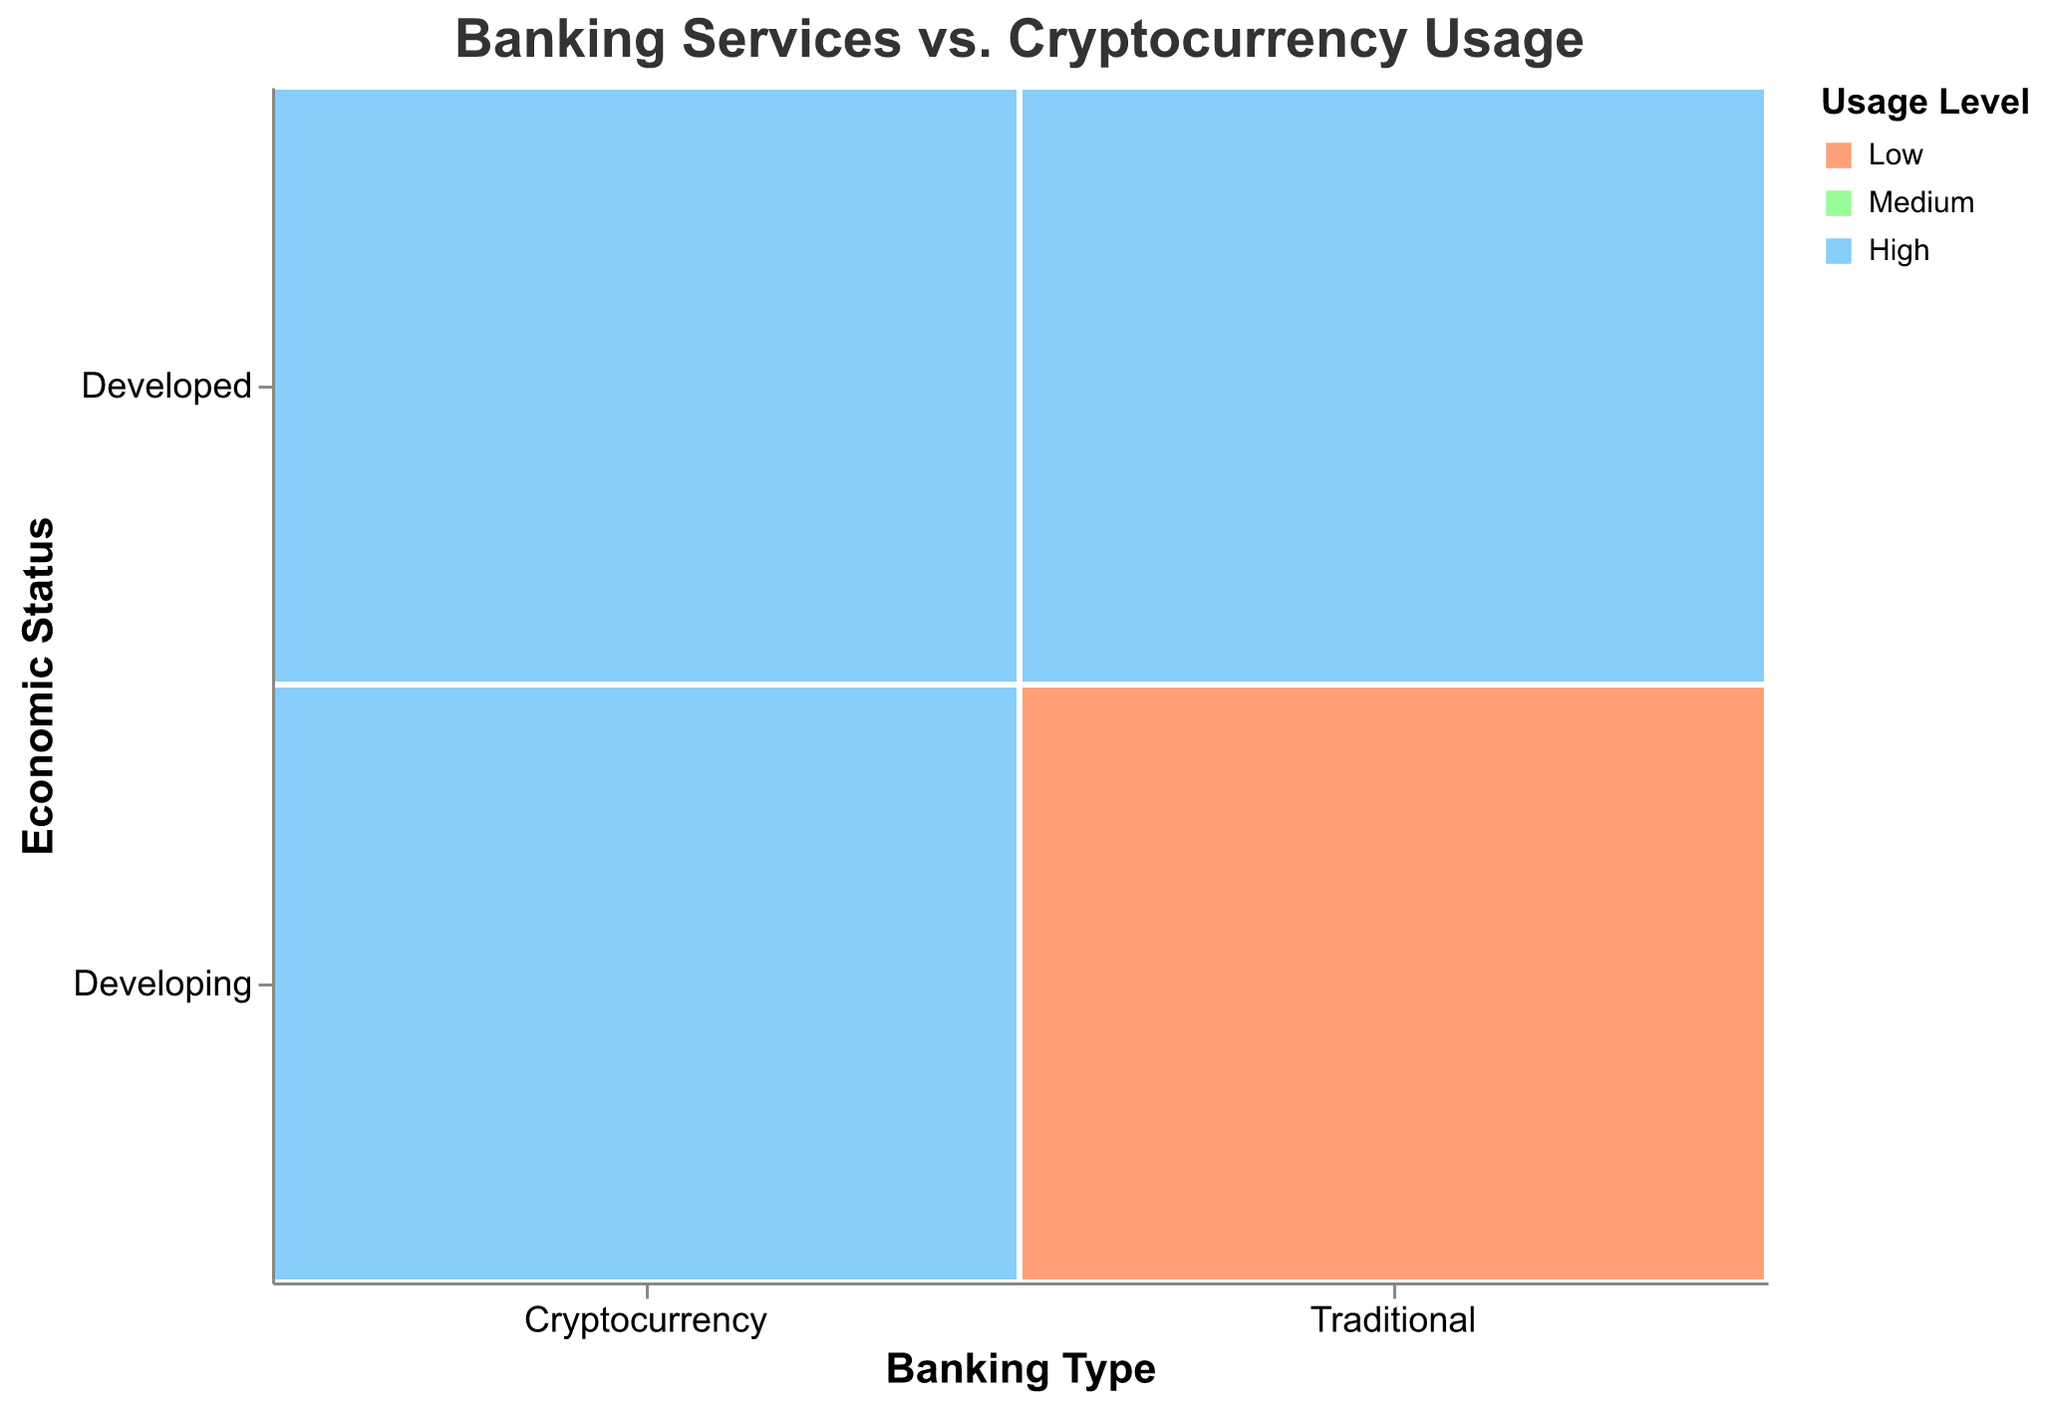What are the main categories displayed on the x-axis and y-axis? The x-axis represents "Banking Type" with two categories (Traditional and Cryptocurrency), and the y-axis represents "Economic Status" with two categories (Developed and Developing).
Answer: Banking Type and Economic Status How many usage levels are represented in the color encoding, and what are they? The color encoding represents three usage levels: Low, Medium, and High.
Answer: Three (Low, Medium, High) Which banking type and economic status combination has the highest usage level for cryptocurrencies? Look for the cryptocurrency section with the High usage level color. In the "Developing" economic status row, countries like Kenya, Brazil, Nigeria, and Venezuela show high usage levels for cryptocurrencies. In the "Developed" economic status row, South Korea also shows high usage levels for cryptocurrencies.
Answer: Developing and Developed (Kenya, Brazil, Nigeria, Venezuela, South Korea) Compare the usage levels of traditional banking services in developed and developing countries. Check the traditional banking sections for "Developed" and "Developing". Developed countries show high usage, while developing countries show medium and low usage.
Answer: Higher in Developed countries Which developed country shows a high usage level for cryptocurrencies? Identify the developed countries on the y-axis and find the one with a high usage level color in the cryptocurrency section. South Korea is the developed country with high usage of cryptocurrencies.
Answer: South Korea What is the usage level of traditional banking services in Nigeria? Locate Nigeria in the developing countries row and look at the traditional banking section. It is colored to represent a low usage level.
Answer: Low How does the usage level of cryptocurrencies in India compare to that in Brazil for developing countries? Check the cryptocurrency section for India and Brazil in the developing countries row. Both have a medium usage level for India and a high usage level for Brazil.
Answer: Brazil has higher usage Which country has low usage levels for both traditional banking services and cryptocurrencies, and what is its economic status? Identify the low usage level color for both banking types and find the corresponding country; it is Germany under Developed economic status for cryptocurrencies and Nigeria and Venezuela for traditional banking under Developing. None have low usage for both.
Answer: None (Germany has low for crypto; Nigeria and Venezuela for traditional) Is there a country with high usage levels for both traditional banking services and cryptocurrencies? Check for high usage levels in both banking types and identify the countries; South Korea in the developed economic status shows high usage levels in both categories.
Answer: South Korea Which country exhibits a medium usage level for both traditional banking services and cryptocurrencies? Look at the medium usage level color for both banking types and identify the country; India in the developing economic status shows medium usage levels in both categories.
Answer: India 